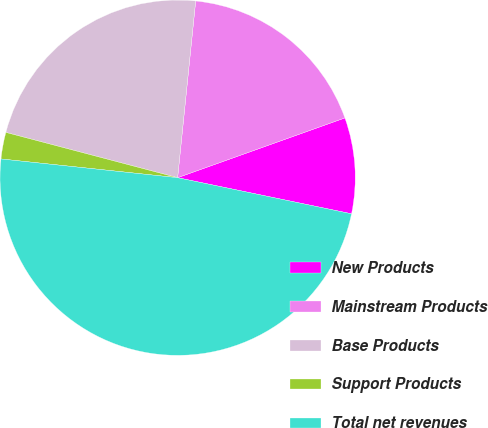<chart> <loc_0><loc_0><loc_500><loc_500><pie_chart><fcel>New Products<fcel>Mainstream Products<fcel>Base Products<fcel>Support Products<fcel>Total net revenues<nl><fcel>8.72%<fcel>17.92%<fcel>22.52%<fcel>2.42%<fcel>48.43%<nl></chart> 